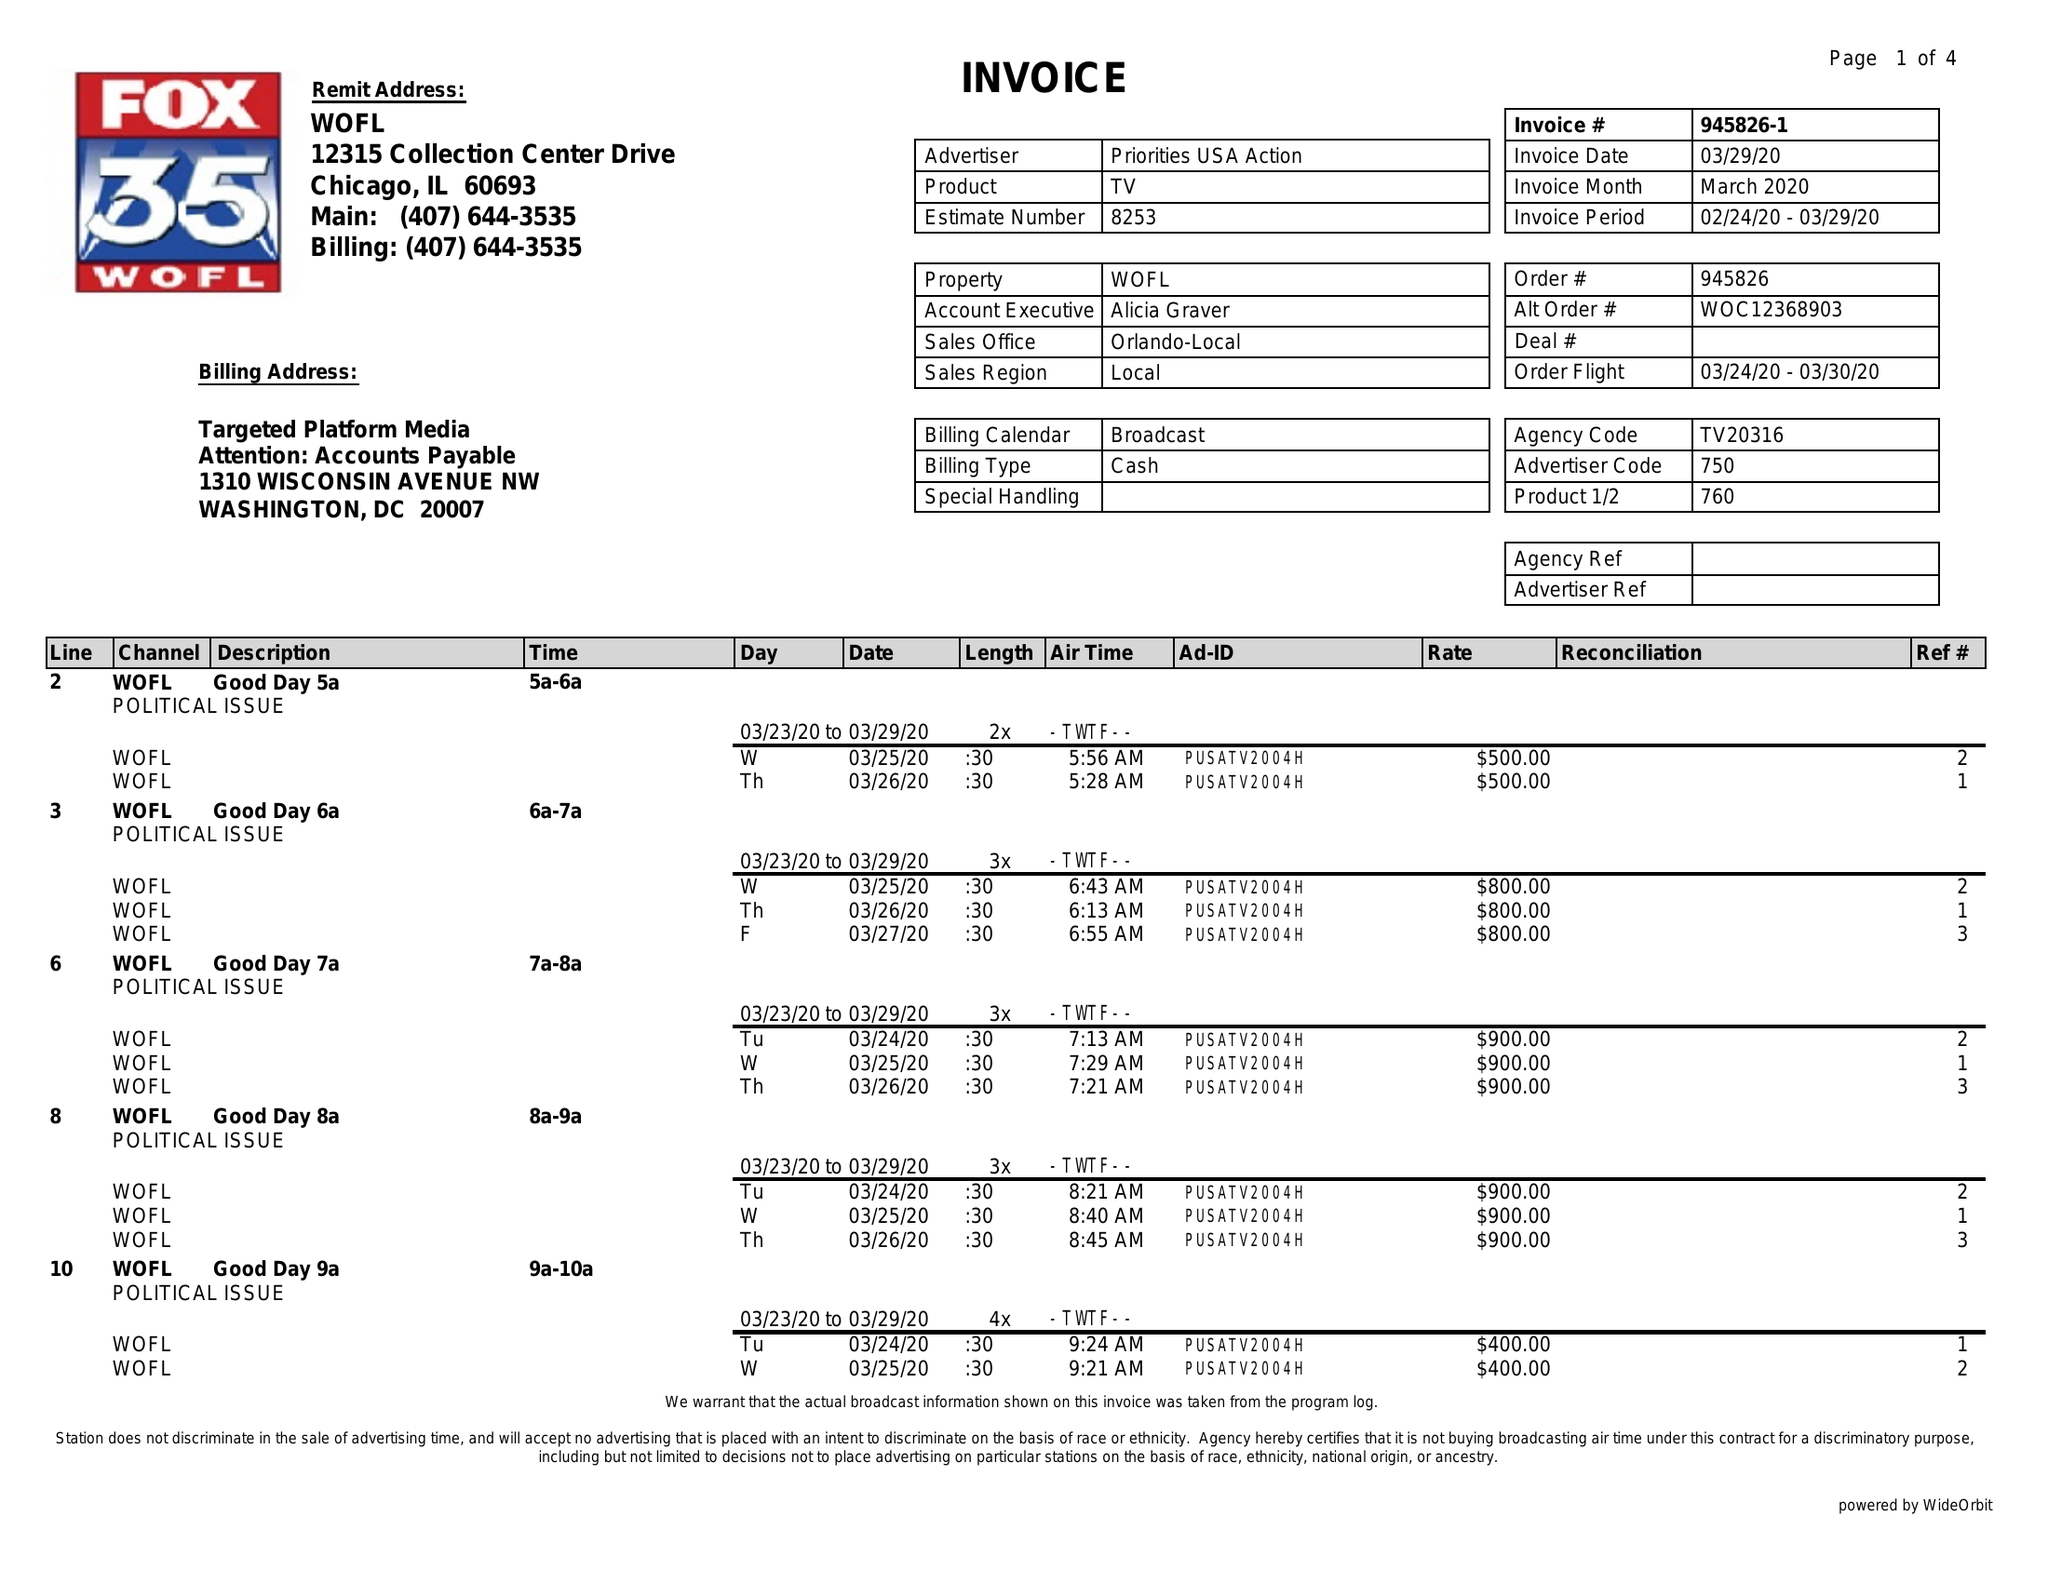What is the value for the advertiser?
Answer the question using a single word or phrase. PRIORITIES USA ACTION 